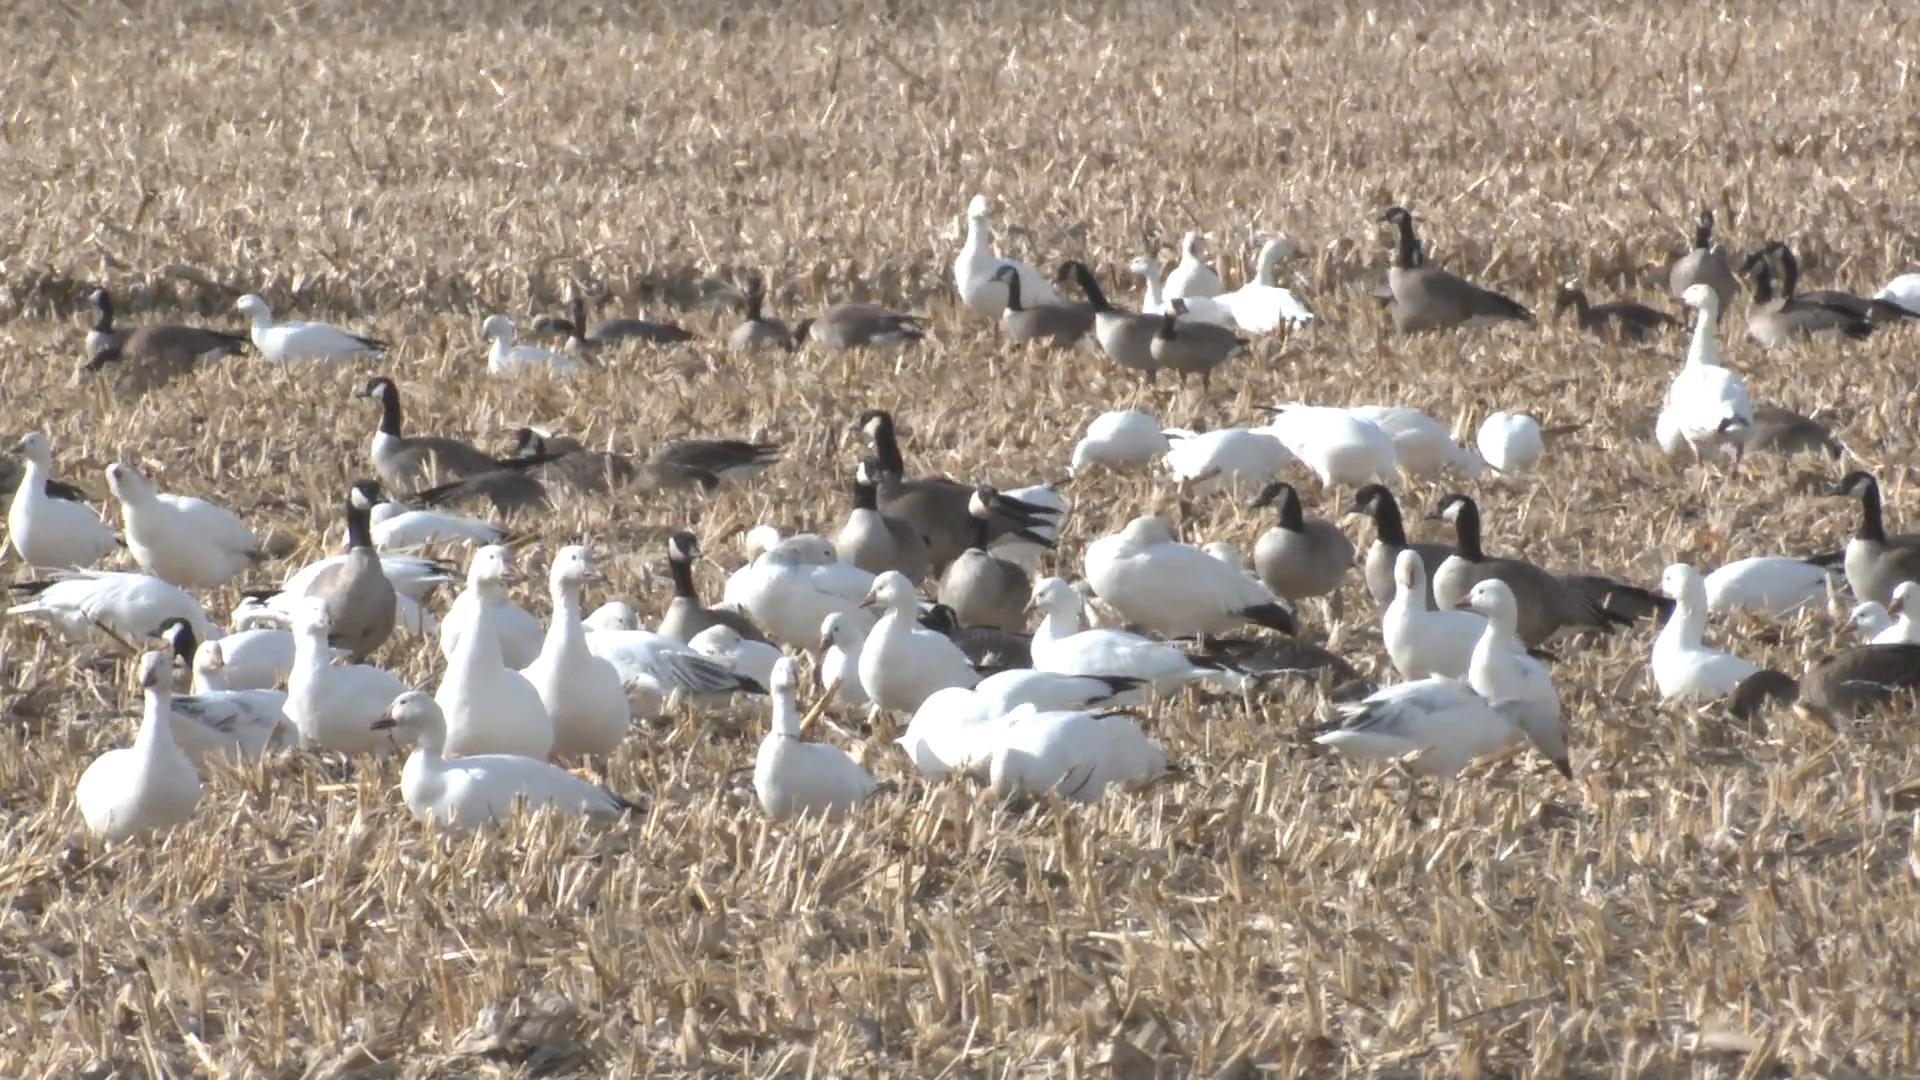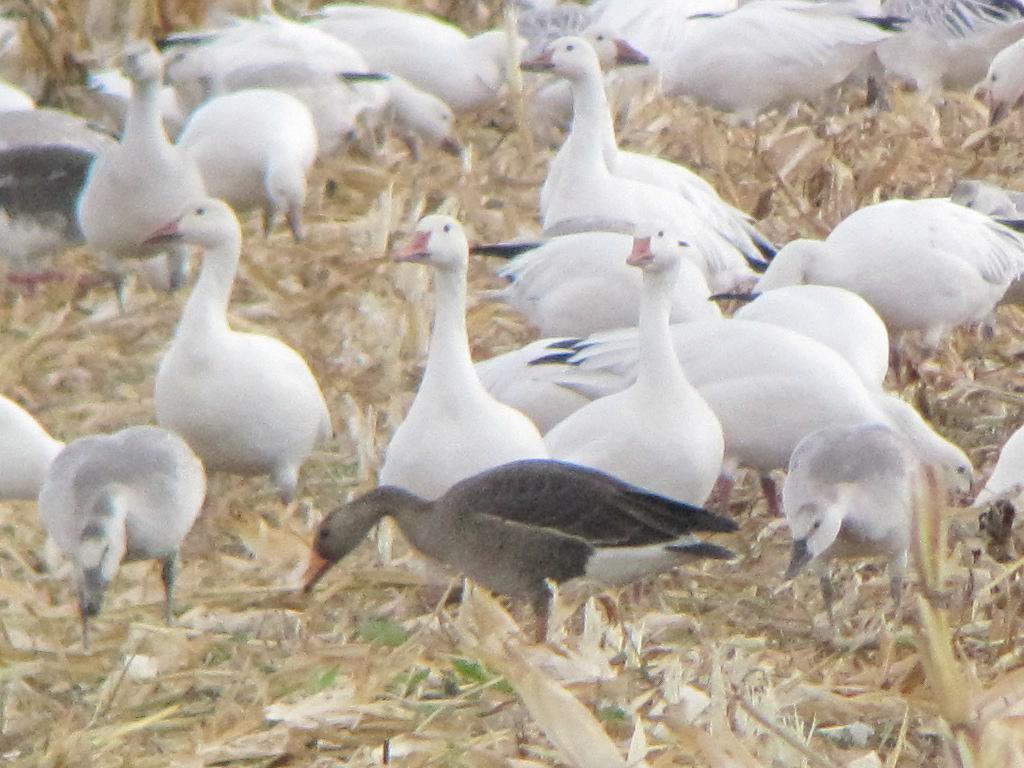The first image is the image on the left, the second image is the image on the right. For the images shown, is this caption "At least one of the images has geese in brown grass." true? Answer yes or no. Yes. The first image is the image on the left, the second image is the image on the right. Analyze the images presented: Is the assertion "There are no more than three birds in the left image." valid? Answer yes or no. No. 